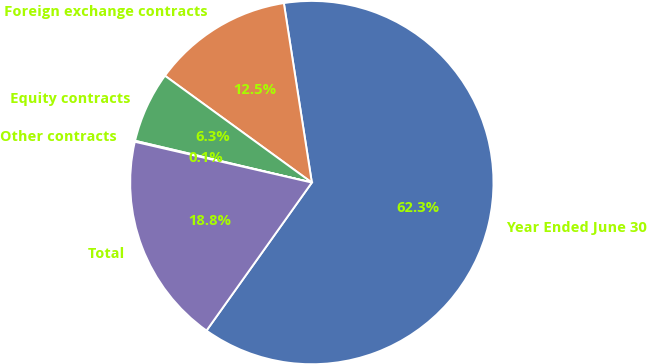Convert chart. <chart><loc_0><loc_0><loc_500><loc_500><pie_chart><fcel>Year Ended June 30<fcel>Foreign exchange contracts<fcel>Equity contracts<fcel>Other contracts<fcel>Total<nl><fcel>62.3%<fcel>12.53%<fcel>6.31%<fcel>0.09%<fcel>18.76%<nl></chart> 